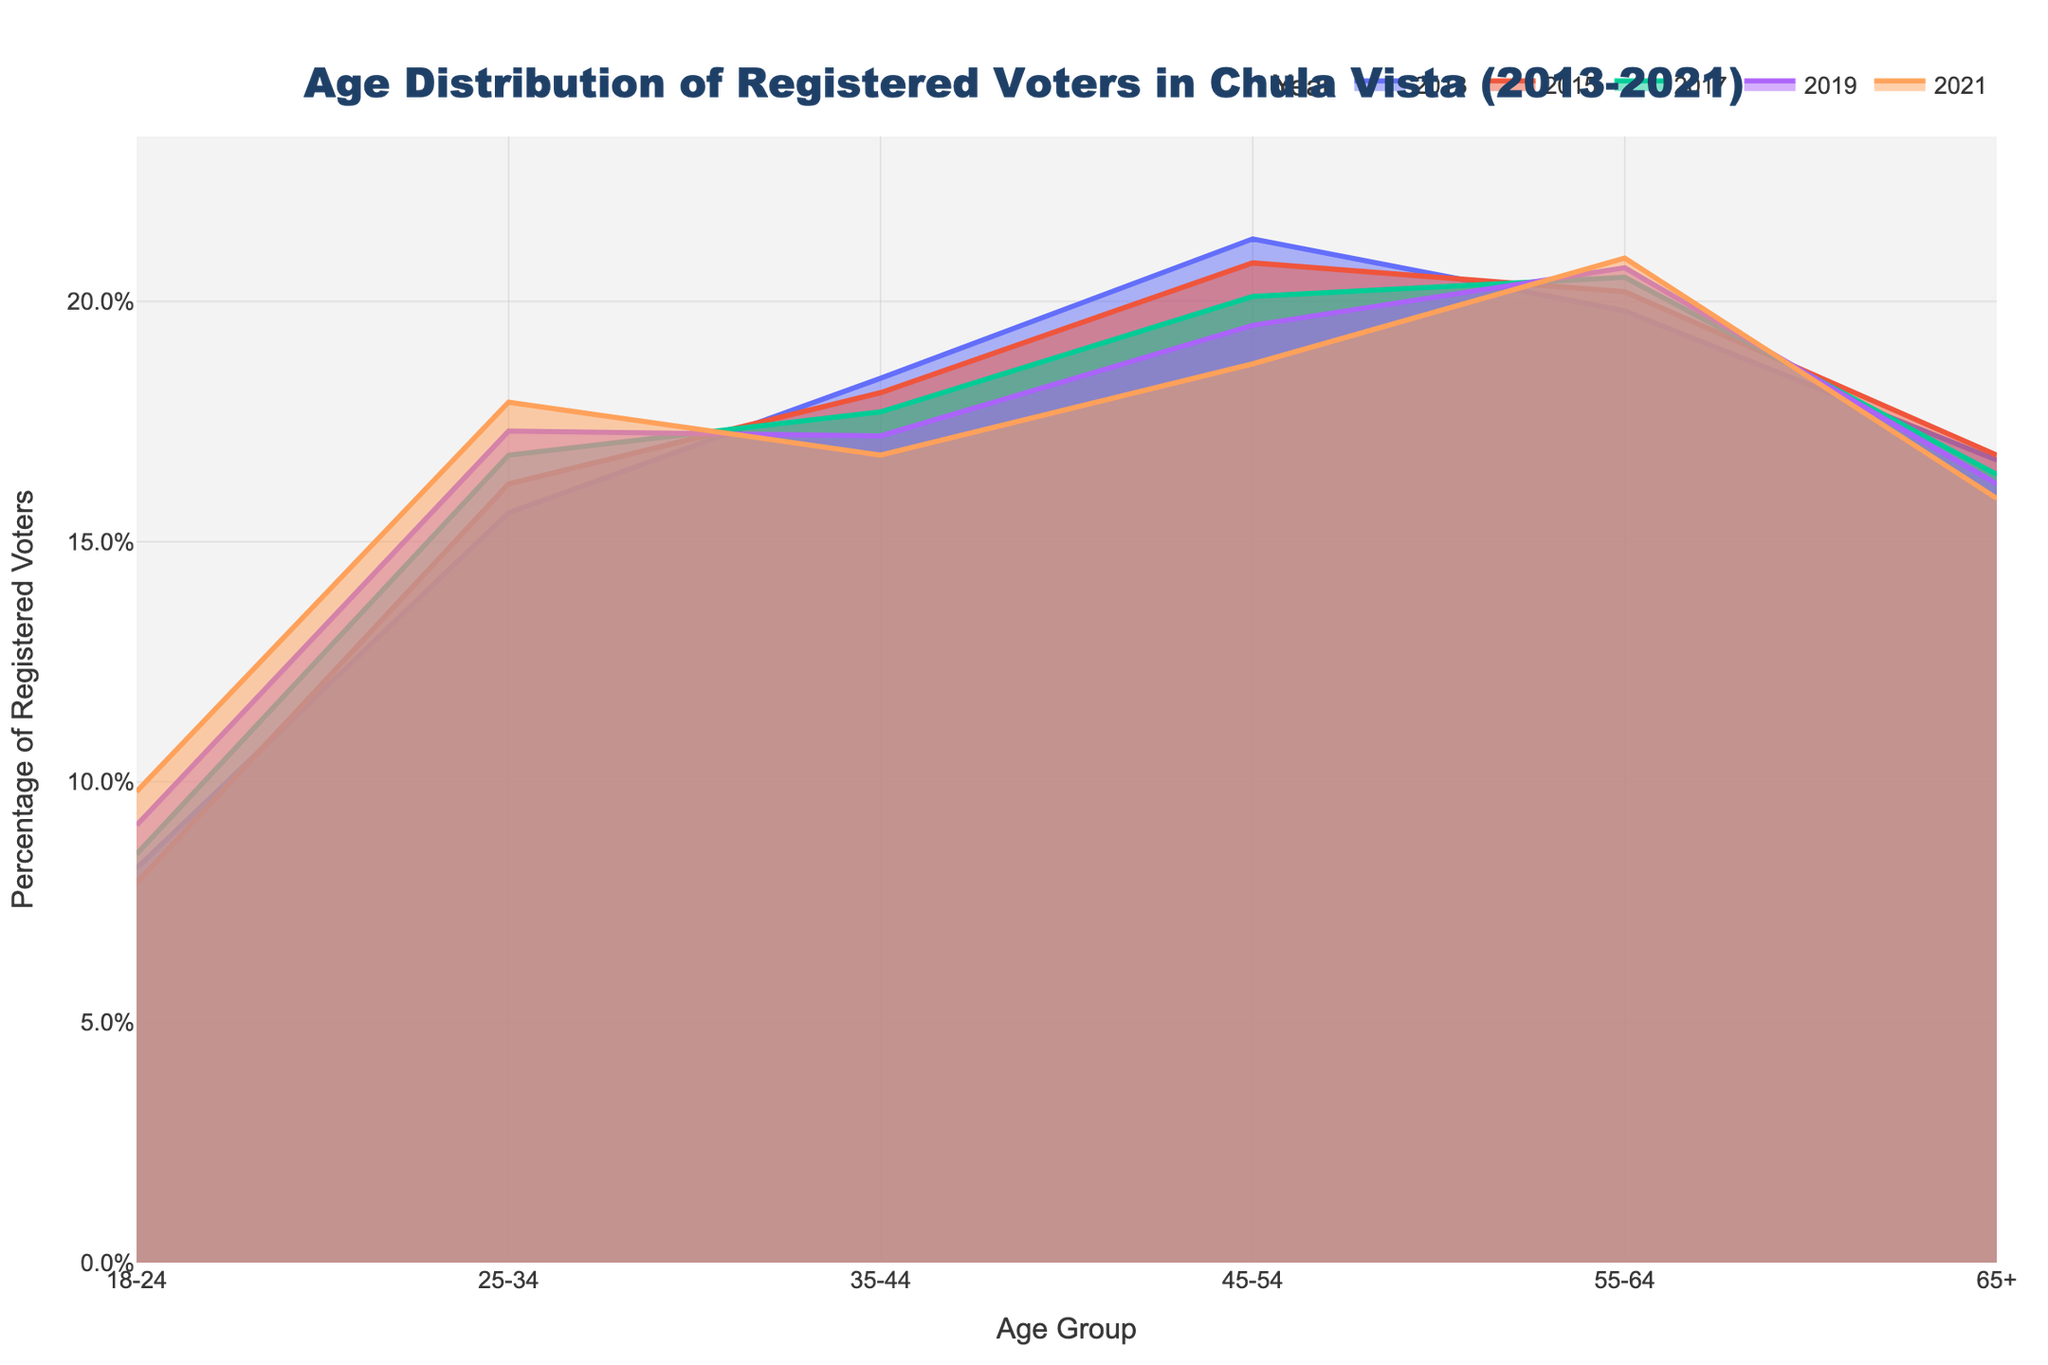What is the title of the density plot? The title is usually placed at the top of the figure and provides a quick summary of what the figure is about. In this case, we can read the title at the top of the plot.
Answer: Age Distribution of Registered Voters in Chula Vista (2013-2021) Which age group observed an increase in the percentage of registered voters each year from 2013 to 2021? Looking at the density plot, we can trace the lines for different years and observe the percentage values for each age group. The age group 18-24 consistently shows an upward trend in percentage from 2013 to 2021.
Answer: 18-24 What age group had the highest percentage of registered voters in 2021? To find this, we need to locate the line representing the year 2021 on the plot and identify the age group with the highest point on that line. The 55-64 age group has the highest percentage in 2021.
Answer: 55-64 How did the percentage of registered voters in the 65+ age group change from 2013 to 2021? To answer this, we'll look at the values for the 65+ age group in the plot for the years 2013 and 2021. The percentage decreased from 16.7% in 2013 to 15.9% in 2021.
Answer: Decreased from 16.7% to 15.9% Which year had the lowest percentage of voters in the 25-34 age group? Following the 25-34 age group in the plot, we can observe the corresponding percentages for each year. The lowest percentage is in 2013 with 15.6%.
Answer: 2013 Compare the percentage of registered voters aged 35-44 in 2013 and 2021. To compare the values, we look at the 35-44 age group for the years 2013 and 2021. In 2013 it was 18.4%, and in 2021 it was 16.8%, indicating a decrease.
Answer: Decreased from 18.4% to 16.8% Which age groups experienced a decrease in the percentage of registered voters over the decade? This involves noting the trend for each age group from 2013 to 2021 and identifying where the values have dropped. The age groups 35-44, 45-54, and 65+ all experienced a decrease.
Answer: 35-44, 45-54, 65+ What year observed the highest percentage of registered voters in the 55-64 age group? By following the 55-64 line across the years, we see that the highest percentage for this age group occurs in 2021 with 20.9%.
Answer: 2021 What was the overall trend for the 45-54 age group from 2013 to 2021? Observing the percentage values for the 45-54 age group across the years, we can notice a downward trend from 21.3% in 2013 to 18.7% in 2021.
Answer: Downward trend Which age group showed the least change in percentage of registered voters over the decade? To determine this, we compare the starting and ending percentages for all age groups. The 25-34 age group had relatively small changes, increasing from 15.6% in 2013 to 17.9% in 2021.
Answer: 25-34 